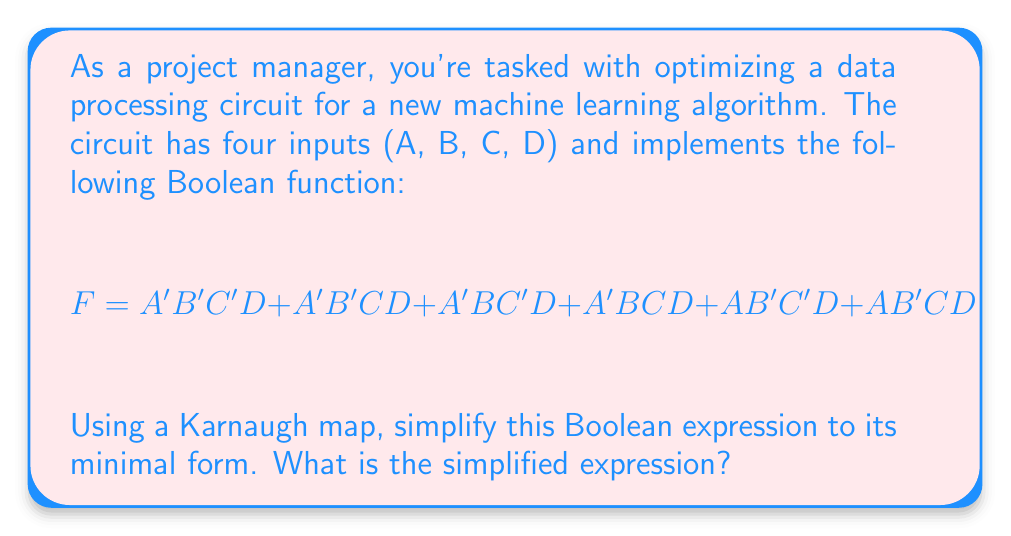Could you help me with this problem? Let's approach this step-by-step:

1) First, we need to create a 4-variable Karnaugh map. The map will have 16 cells (2^4).

2) We'll fill in the Karnaugh map based on the given function:

   [asy]
   unitsize(1cm);
   
   for(int i=0; i<5; ++i) {
     draw((i,0)--(i,4));
     draw((0,i)--(4,i));
   }
   
   label("AB\CD", (0,4.5));
   label("00", (1,4.5)); label("01", (2,4.5)); label("11", (3,4.5)); label("10", (4,4.5));
   label("00", (-0.5,3.5)); label("01", (-0.5,2.5)); label("11", (-0.5,1.5)); label("10", (-0.5,0.5));
   
   label("1", (1.5,3.5)); label("1", (2.5,3.5)); label("1", (3.5,3.5)); label("1", (4.5,3.5));
   label("1", (1.5,2.5)); label("1", (2.5,2.5));
   
   [/asy]

3) Now we look for the largest possible groupings of 1s. We can see two groups:
   - A group of 4 in the top row (A'D)
   - A group of 2 in the second row (A'BC)

4) These groups translate to the following terms:
   - A'D (the group of 4)
   - A'BC (the group of 2)

5) The simplified expression is the OR of these terms.
Answer: $F = A'D + A'BC$ 